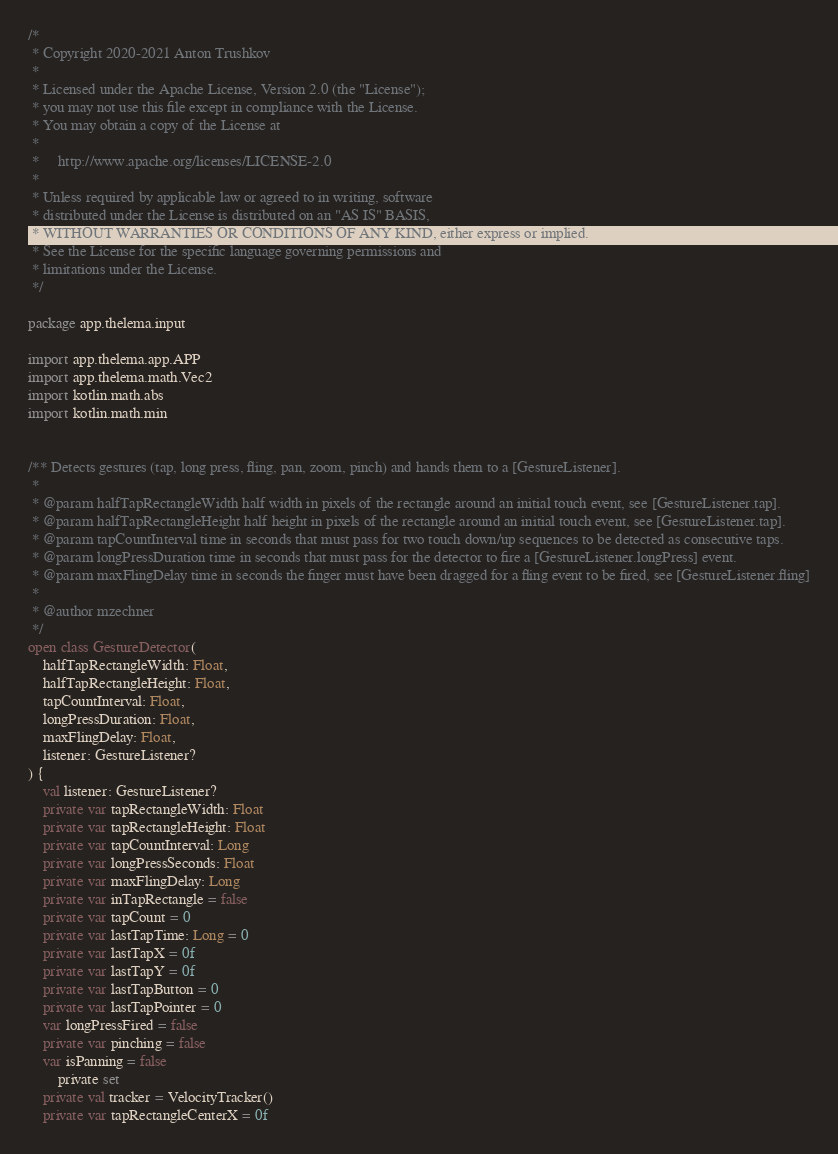<code> <loc_0><loc_0><loc_500><loc_500><_Kotlin_>/*
 * Copyright 2020-2021 Anton Trushkov
 *
 * Licensed under the Apache License, Version 2.0 (the "License");
 * you may not use this file except in compliance with the License.
 * You may obtain a copy of the License at
 *
 *     http://www.apache.org/licenses/LICENSE-2.0
 *
 * Unless required by applicable law or agreed to in writing, software
 * distributed under the License is distributed on an "AS IS" BASIS,
 * WITHOUT WARRANTIES OR CONDITIONS OF ANY KIND, either express or implied.
 * See the License for the specific language governing permissions and
 * limitations under the License.
 */

package app.thelema.input

import app.thelema.app.APP
import app.thelema.math.Vec2
import kotlin.math.abs
import kotlin.math.min


/** Detects gestures (tap, long press, fling, pan, zoom, pinch) and hands them to a [GestureListener].
 * 
 * @param halfTapRectangleWidth half width in pixels of the rectangle around an initial touch event, see [GestureListener.tap].
 * @param halfTapRectangleHeight half height in pixels of the rectangle around an initial touch event, see [GestureListener.tap].
 * @param tapCountInterval time in seconds that must pass for two touch down/up sequences to be detected as consecutive taps.
 * @param longPressDuration time in seconds that must pass for the detector to fire a [GestureListener.longPress] event.
 * @param maxFlingDelay time in seconds the finger must have been dragged for a fling event to be fired, see [GestureListener.fling]
 * 
 * @author mzechner
 */
open class GestureDetector(
    halfTapRectangleWidth: Float,
    halfTapRectangleHeight: Float,
    tapCountInterval: Float,
    longPressDuration: Float,
    maxFlingDelay: Float,
    listener: GestureListener?
) {
    val listener: GestureListener?
    private var tapRectangleWidth: Float
    private var tapRectangleHeight: Float
    private var tapCountInterval: Long
    private var longPressSeconds: Float
    private var maxFlingDelay: Long
    private var inTapRectangle = false
    private var tapCount = 0
    private var lastTapTime: Long = 0
    private var lastTapX = 0f
    private var lastTapY = 0f
    private var lastTapButton = 0
    private var lastTapPointer = 0
    var longPressFired = false
    private var pinching = false
    var isPanning = false
        private set
    private val tracker = VelocityTracker()
    private var tapRectangleCenterX = 0f</code> 